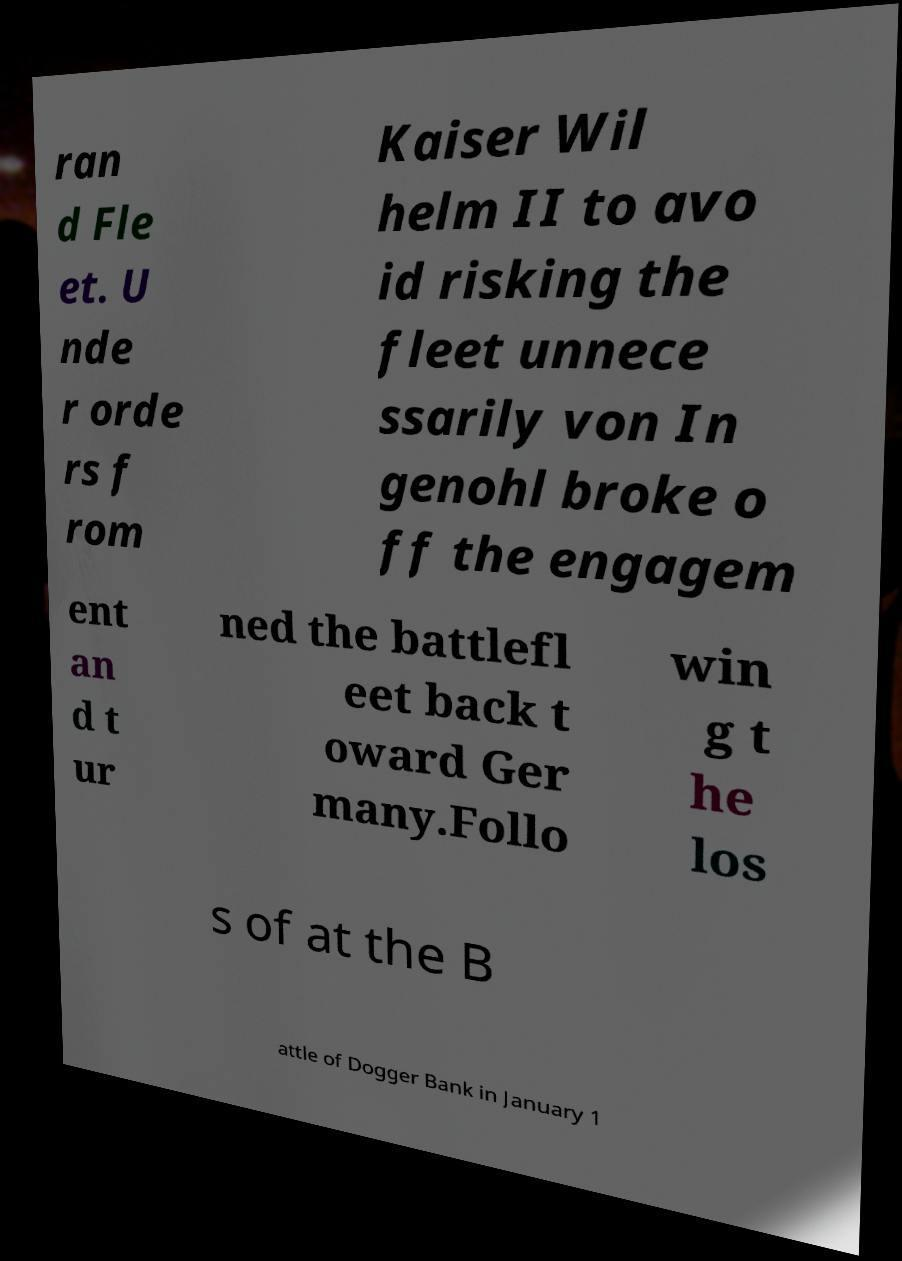Can you accurately transcribe the text from the provided image for me? ran d Fle et. U nde r orde rs f rom Kaiser Wil helm II to avo id risking the fleet unnece ssarily von In genohl broke o ff the engagem ent an d t ur ned the battlefl eet back t oward Ger many.Follo win g t he los s of at the B attle of Dogger Bank in January 1 